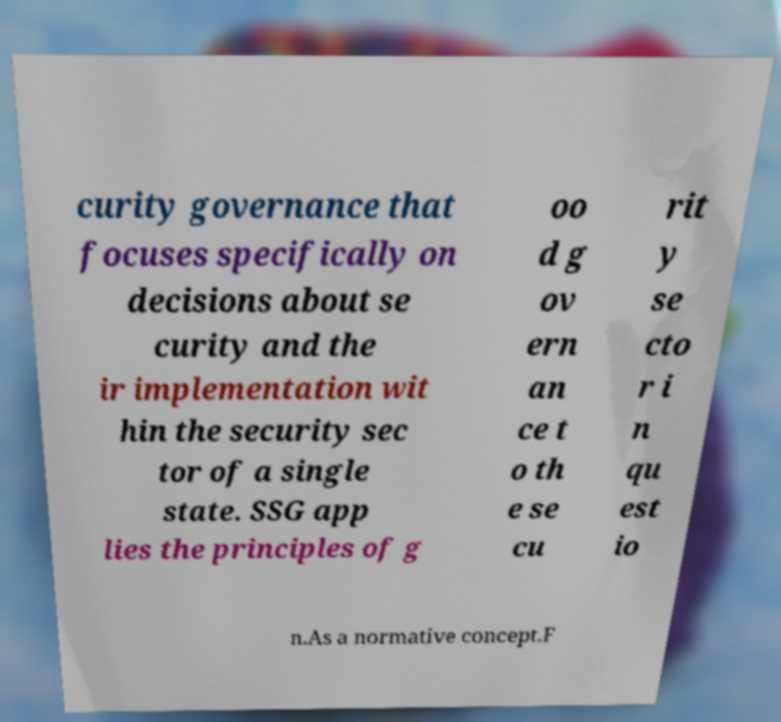Could you assist in decoding the text presented in this image and type it out clearly? curity governance that focuses specifically on decisions about se curity and the ir implementation wit hin the security sec tor of a single state. SSG app lies the principles of g oo d g ov ern an ce t o th e se cu rit y se cto r i n qu est io n.As a normative concept.F 